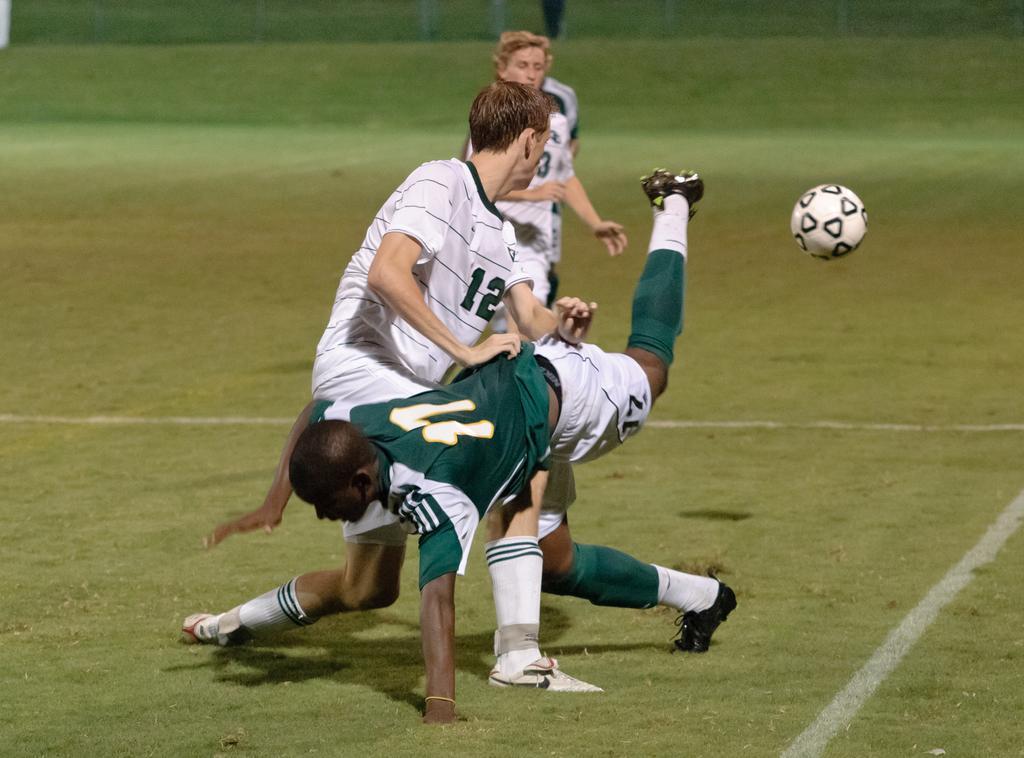Please provide a concise description of this image. This image is taken outdoors. At the bottom of the image there is a ground with grass on it. In the background there is a person and two men are running on the ground to catch a ball. In the middle of the image a man is running and there is another man. 